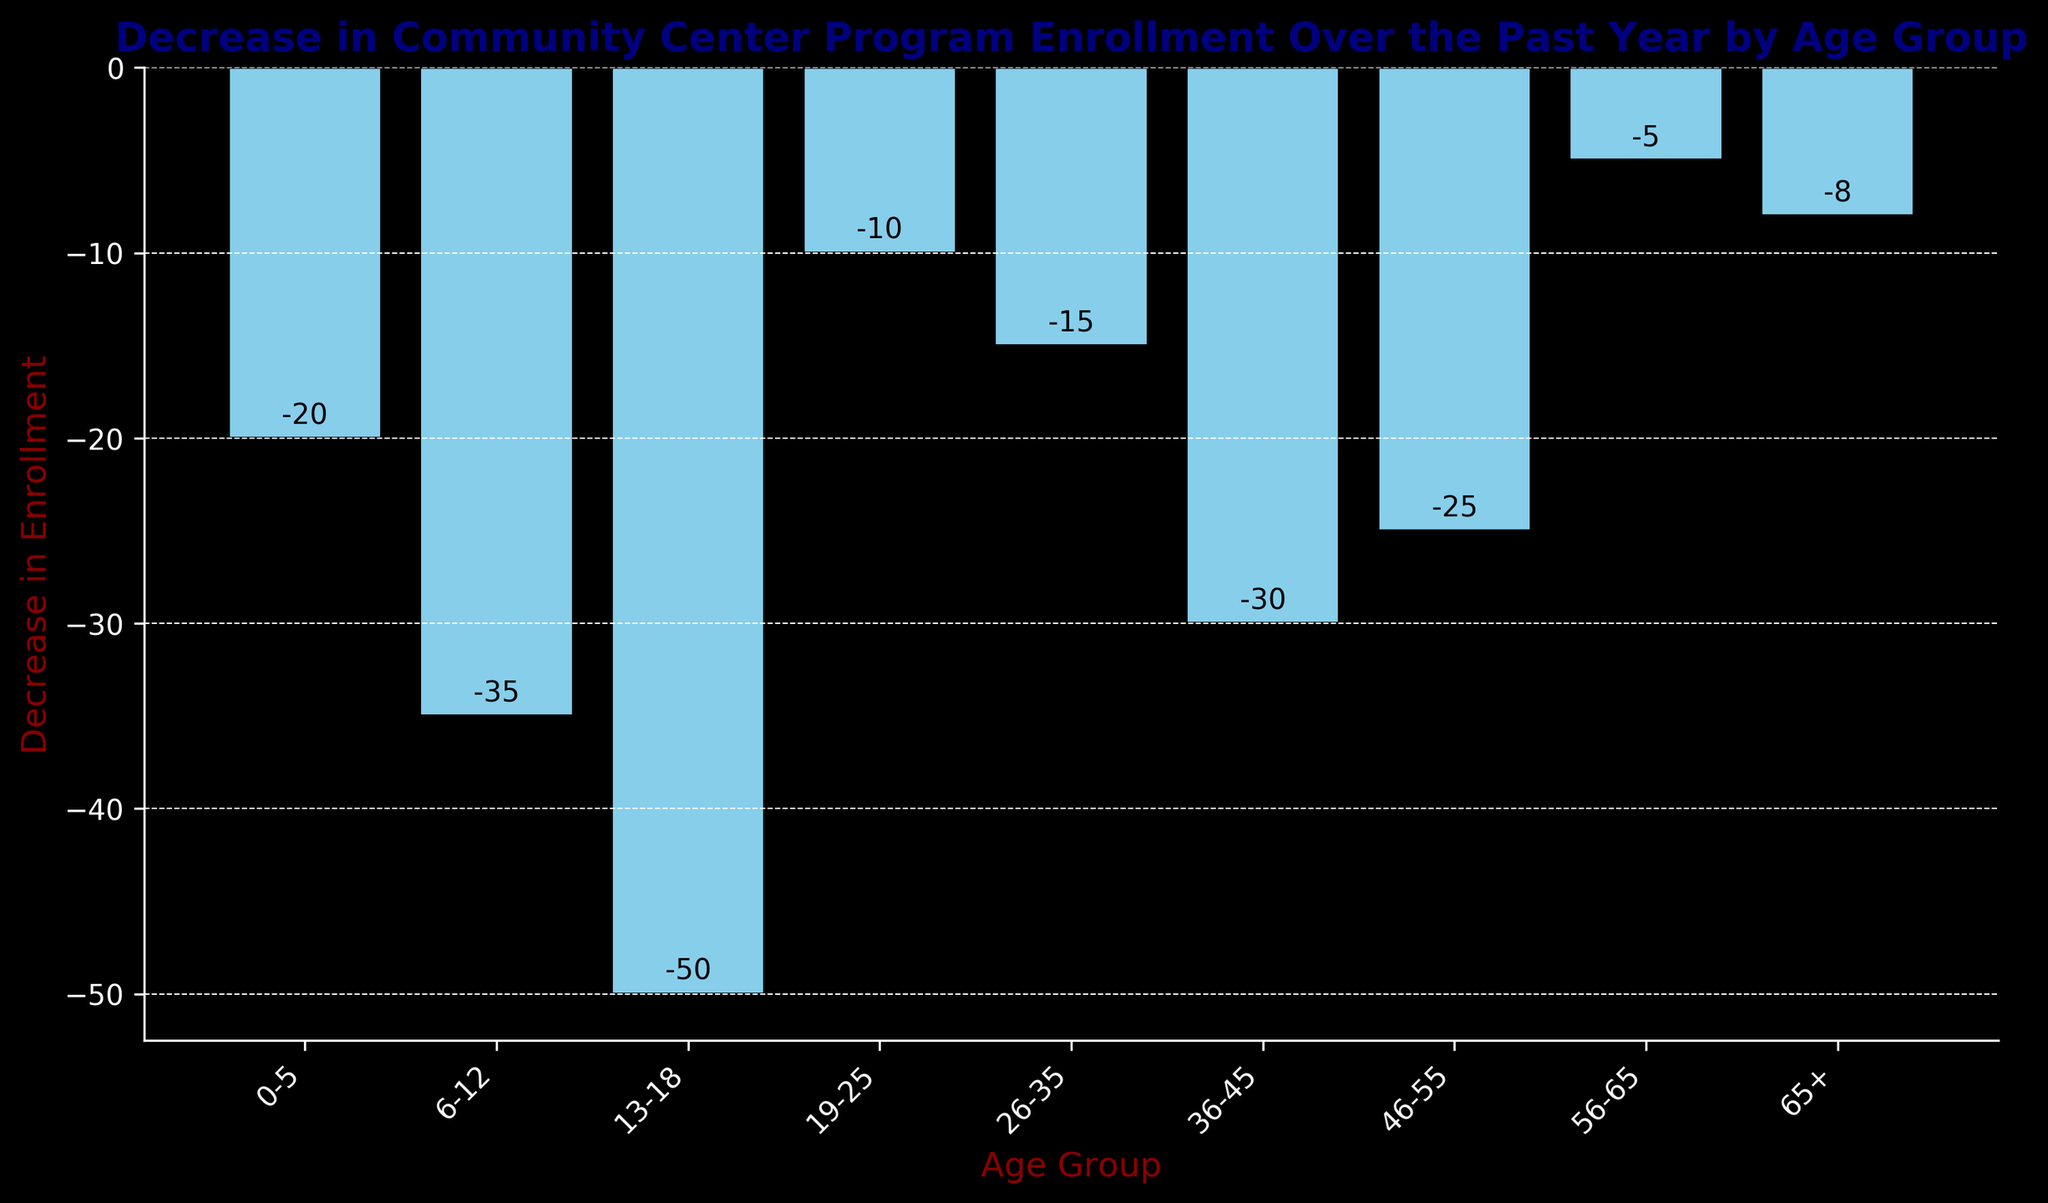Which age group experienced the highest decrease in enrollment? The age group with the tallest bar in the negative direction is the one with the highest decrease. The bar for the 13-18 age group is the tallest in the negative direction at -50.
Answer: 13-18 Which age group had the smallest decrease in enrollment? To find the smallest decrease, look for the shortest bar in the negative direction. The 56-65 age group has the shortest bar at -5.
Answer: 56-65 How does the decrease in enrollment for the 19-25 age group compare to the 26-35 age group? Compare the heights of the bars for each age group. The 19-25 age group has a decrease of -10, and the 26-35 age group has a decrease of -15. The 19-25 decrease is smaller than the 26-35's.
Answer: The 19-25 age group had a smaller decrease What is the total decrease in enrollment for the age groups 0-5 and 6-12 combined? Sum the values for these two age groups: -20 (0-5) + -35 (6-12) = -55.
Answer: -55 Which two age groups have a combined decrease equal to -55? Find two bars whose combined heights sum to -55. The 0-5 and 6-12 age groups both combine to -55.
Answer: 0-5 and 6-12 Which age group's decrease in enrollment is closest to -25? Compare the bar heights to -25. The 46-55 age group has a decrease of -25, which is exactly equal to -25.
Answer: 46-55 What is the average decrease in enrollment for all age groups? Sum all decreases and divide by the number of age groups. Sum = -20 - 35 - 50 - 10 - 15 - 30 - 25 - 5 - 8 = -198; Average = -198 / 9 ≈ -22
Answer: -22 What is the difference in the decrease in enrollment between the age groups 6-12 and 36-45? Subtract the decrease of 36-45 from 6-12: -35 - (-30) = -5.
Answer: -5 Which age group experienced a decrease that is twice as much as the 56-65 age group? The 56-65 age group experienced a decrease of -5. The group with a decrease twice as much will have -10. The 19-25 age group has a decrease of -10.
Answer: 19-25 What is the median decrease in enrollment across all age groups? Arrange the decreases in order: -50, -35, -30, -25, -20, -15, -10, -8, -5. The median is the middle value, which is the 5th value: -20.
Answer: -20 